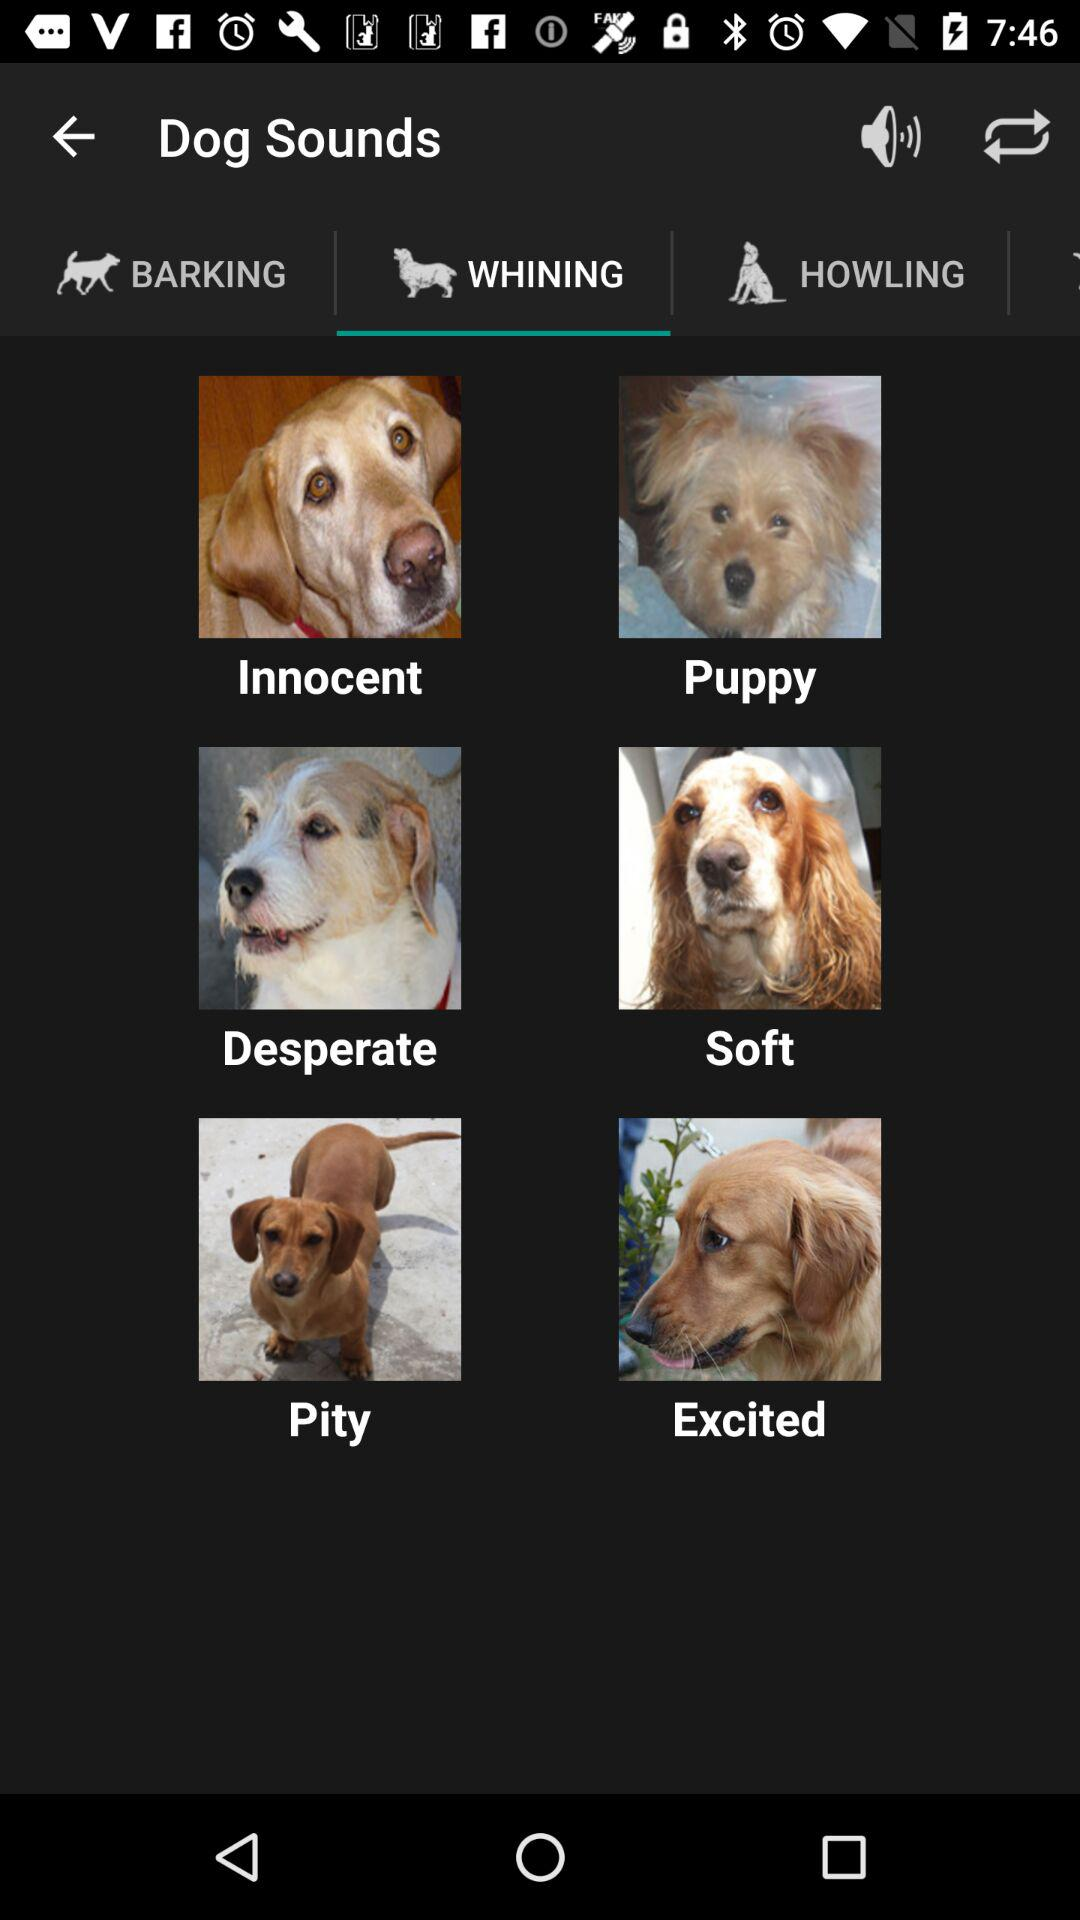Which is the selected tab? The selected tab is "WHINING". 